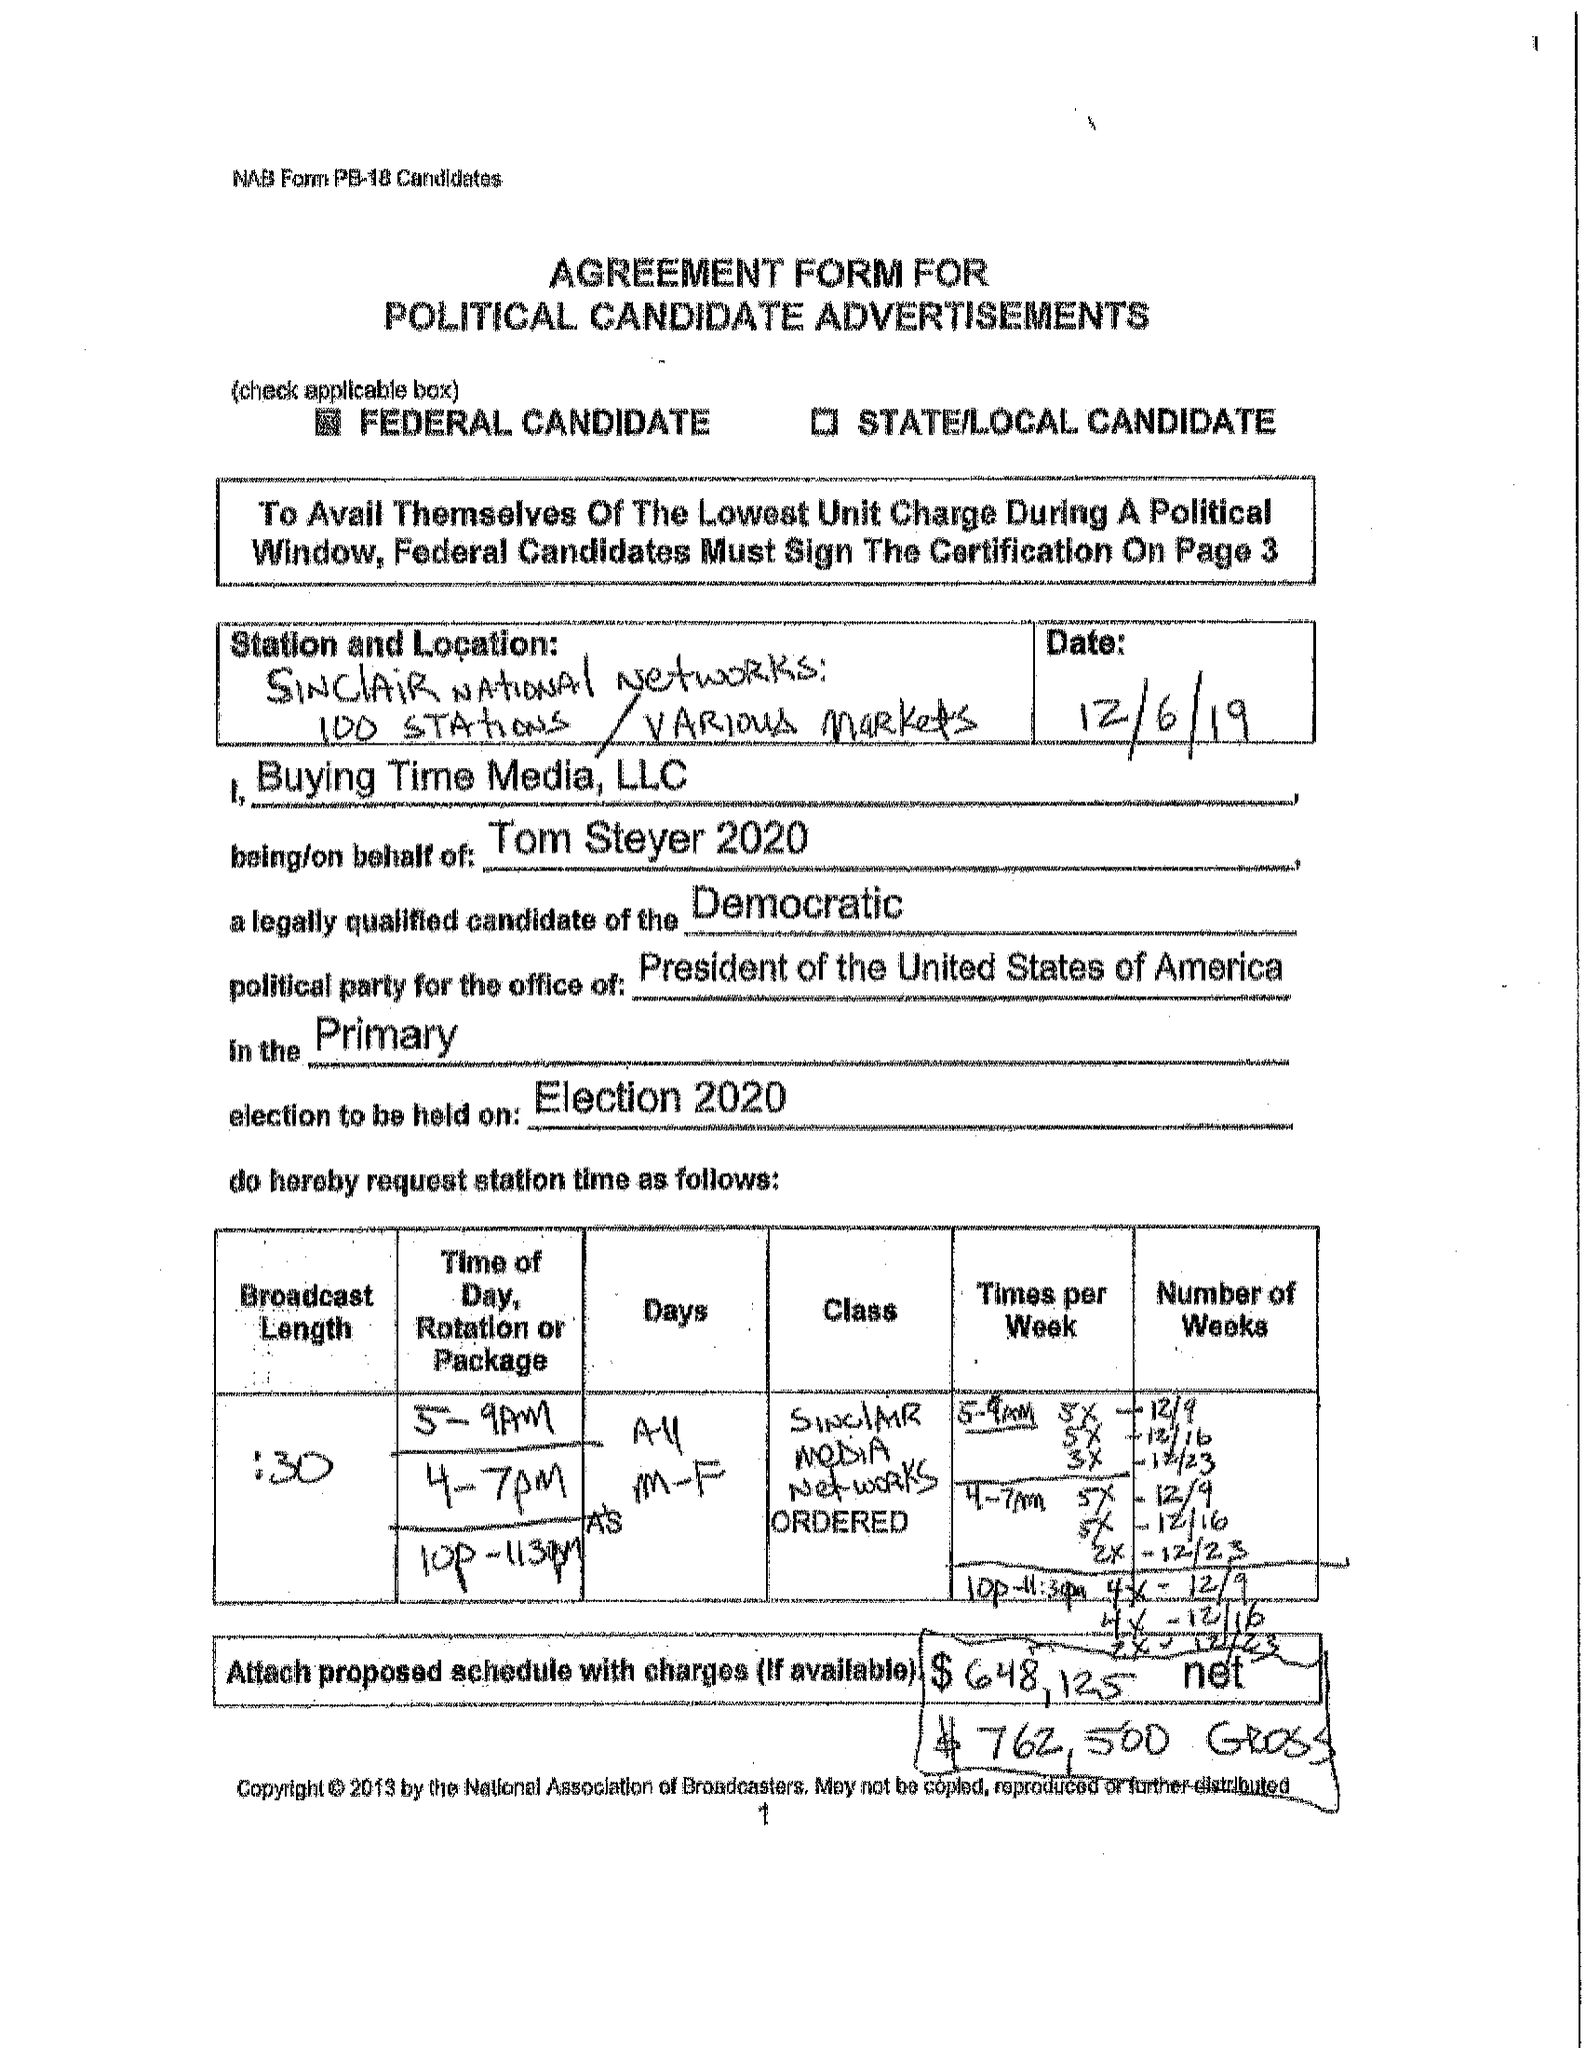What is the value for the flight_from?
Answer the question using a single word or phrase. 12/09/19 